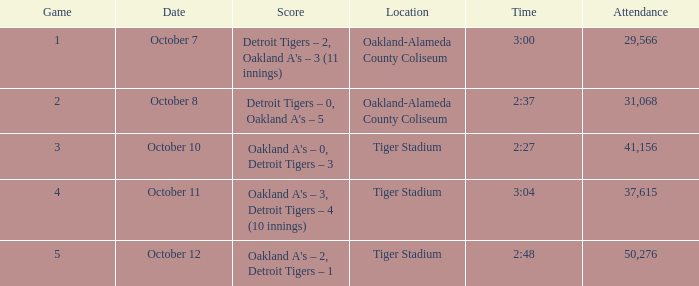What was the score at Tiger Stadium on October 12? Oakland A's – 2, Detroit Tigers – 1. 